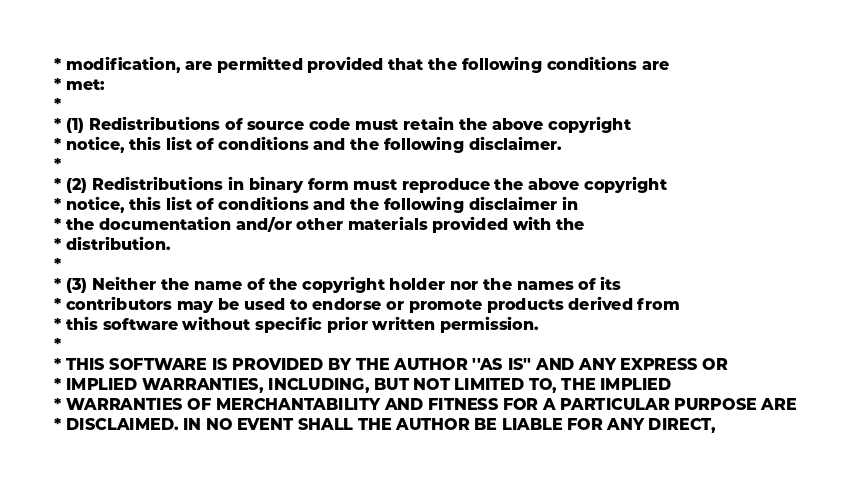Convert code to text. <code><loc_0><loc_0><loc_500><loc_500><_PHP_>* modification, are permitted provided that the following conditions are
* met:
*
* (1) Redistributions of source code must retain the above copyright
* notice, this list of conditions and the following disclaimer.
*
* (2) Redistributions in binary form must reproduce the above copyright
* notice, this list of conditions and the following disclaimer in
* the documentation and/or other materials provided with the
* distribution.
*
* (3) Neither the name of the copyright holder nor the names of its
* contributors may be used to endorse or promote products derived from
* this software without specific prior written permission.
*
* THIS SOFTWARE IS PROVIDED BY THE AUTHOR ''AS IS'' AND ANY EXPRESS OR
* IMPLIED WARRANTIES, INCLUDING, BUT NOT LIMITED TO, THE IMPLIED
* WARRANTIES OF MERCHANTABILITY AND FITNESS FOR A PARTICULAR PURPOSE ARE
* DISCLAIMED. IN NO EVENT SHALL THE AUTHOR BE LIABLE FOR ANY DIRECT,</code> 